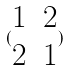Convert formula to latex. <formula><loc_0><loc_0><loc_500><loc_500>( \begin{matrix} 1 & 2 \\ 2 & 1 \end{matrix} )</formula> 